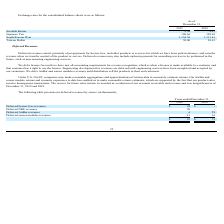From Neonode's financial document, How much was the deferred AirBar revenues for the year ended December 31, 2018, and 2019, respectively? The document shows two values: 16 and 13 (in thousands). From the document: "Deferred sensor modules revenues 13 16 Deferred sensor modules revenues 13 16..." Also, can you calculate: What is the proportion of deferred license fees and NRE revenues over total deferred revenues for the year ended December 31, 2019? To answer this question, I need to perform calculations using the financial data. The calculation is: (28+20)/67 , which equals 0.72. This is based on the information: "Deferred license fees revenues $ 28 $ - $ 67 $ 75 2019 2018..." The key data points involved are: 20, 28, 67. Also, can you calculate: What is the percentage change of deferred sensor module revenues from 2018 to 2019? To answer this question, I need to perform calculations using the financial data. The calculation is: (13-16)/16 , which equals -18.75 (percentage). This is based on the information: "Deferred sensor modules revenues 13 16 Deferred sensor modules revenues 13 16..." The key data points involved are: 13, 16. Also, can you calculate: What are the total deferred revenues for both 2018 and 2019? Based on the calculation: $67+$75, the result is 142 (in thousands). This is based on the information: "$ 67 $ 75 $ 67 $ 75..." The key data points involved are: 67, 75. Also, What do deferred revenues primarily consist of?  prepayments for license fees, and other products or services for which we have been paid in advance, and earn the revenue when we transfer control of the product or service. The document states: "Deferred revenues consist primarily of prepayments for license fees, and other products or services for which we have been paid in advance, and earn t..." Also, How does the reserve for future sales returns being recorded? as a reduction of our accounts receivable. The document states: "The reserve for future sales returns is recorded as a reduction of our accounts receivable and revenue and was insignificant as of December 31, 2019 a..." 